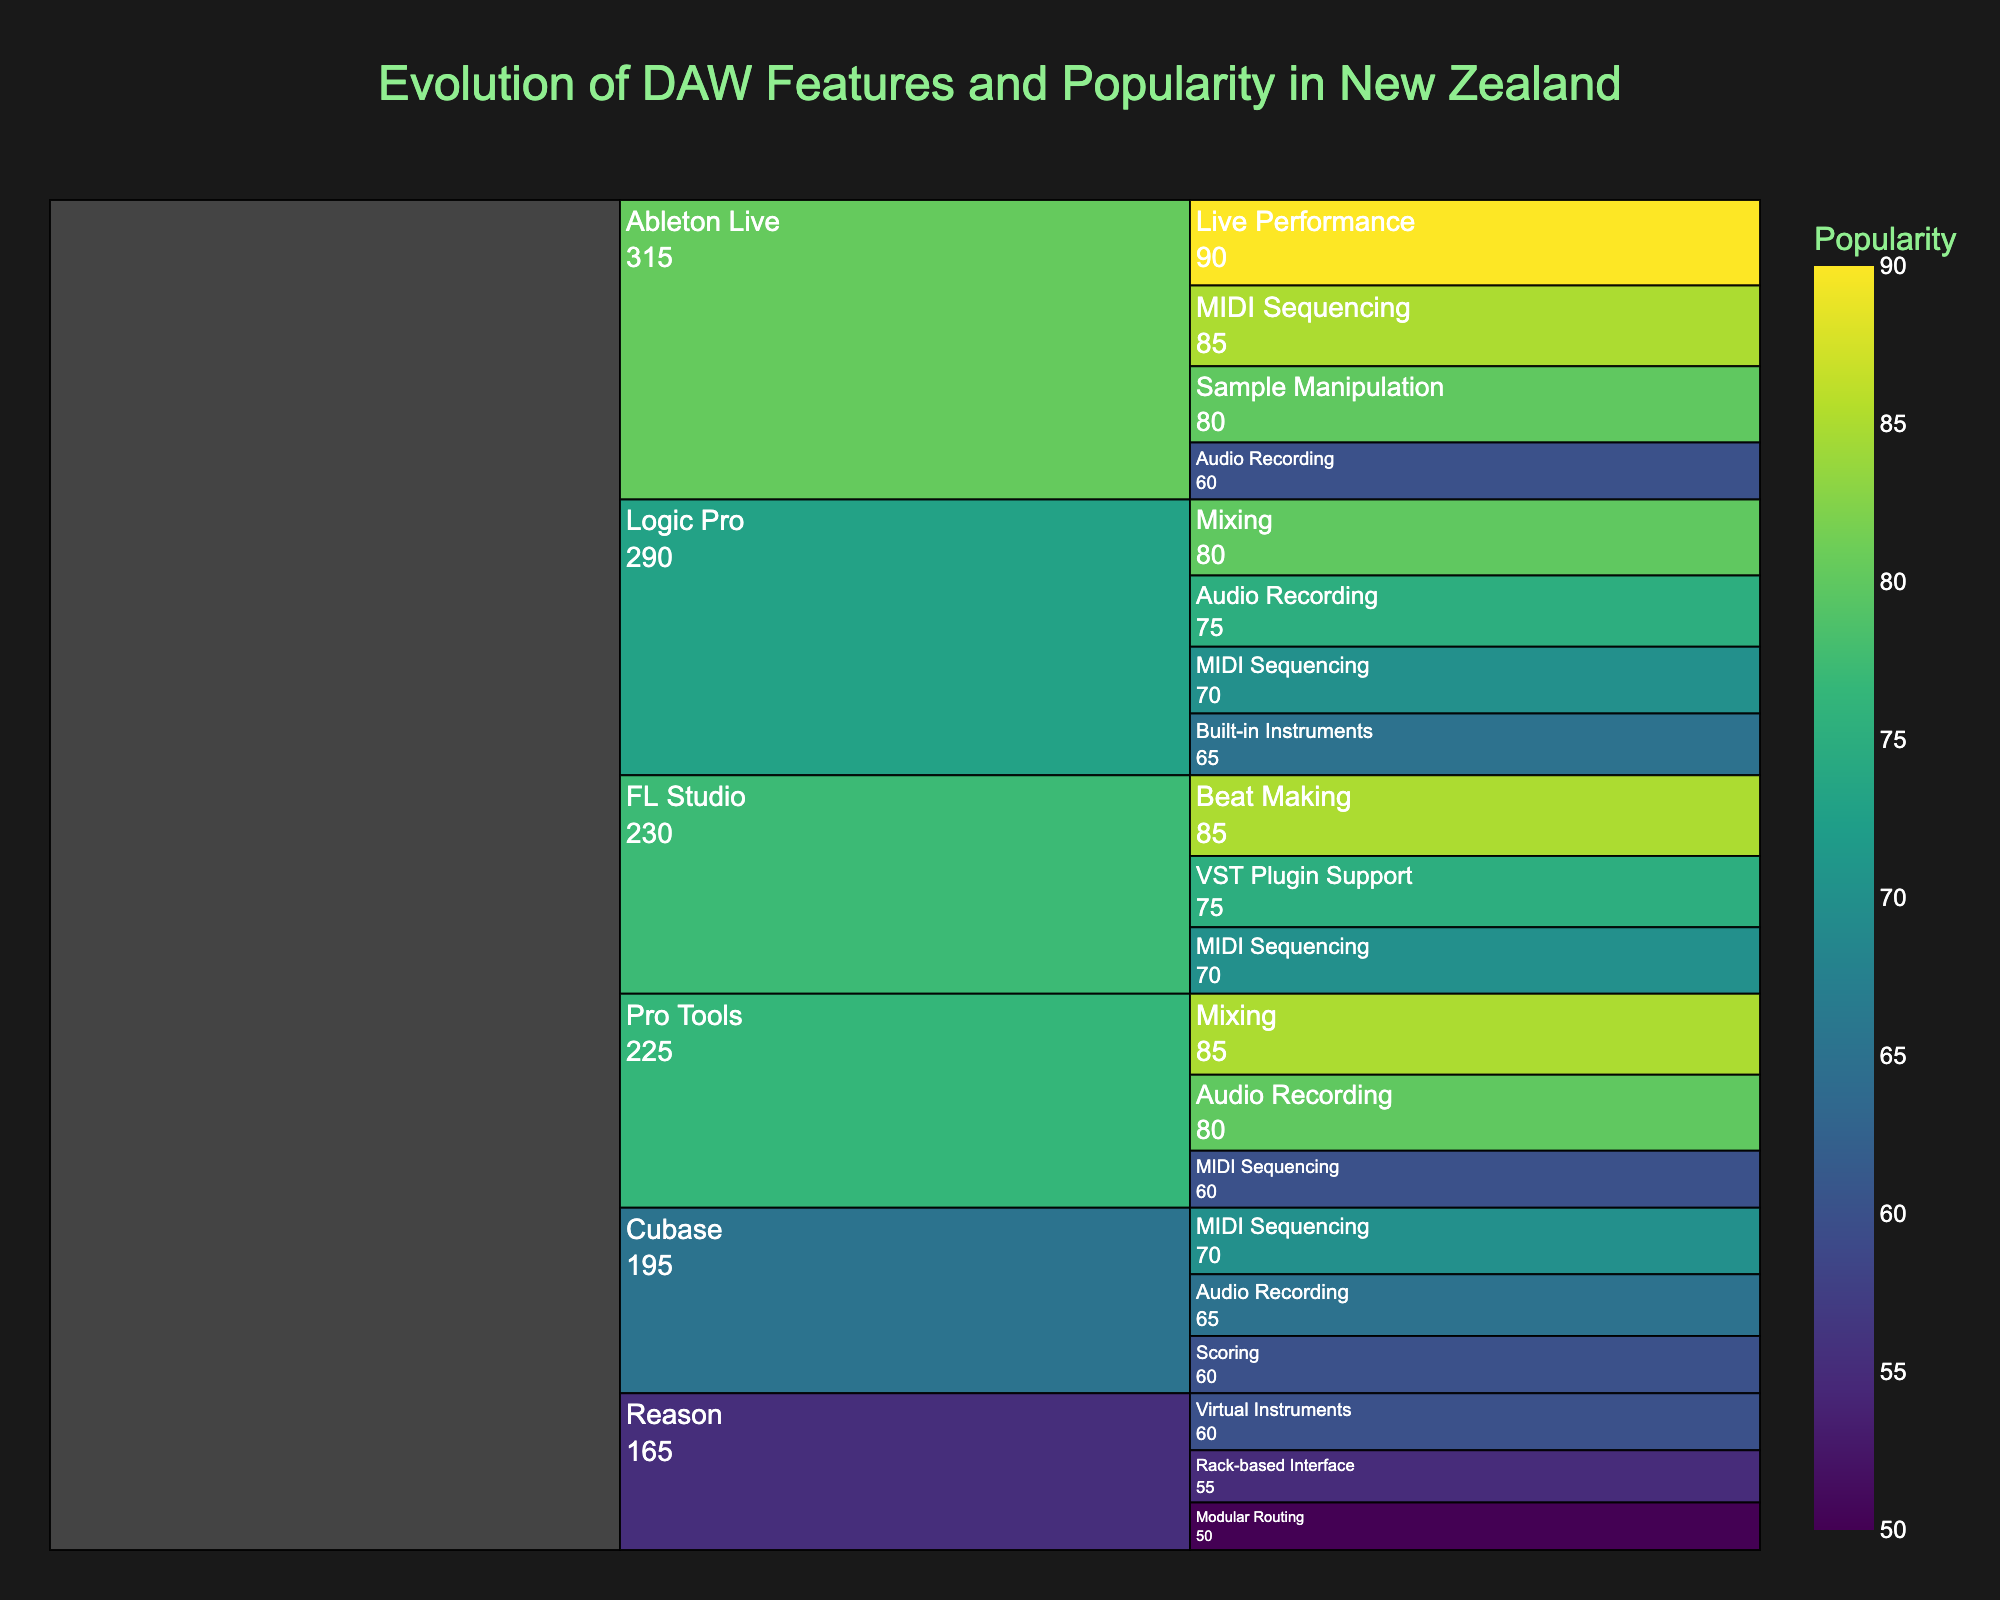What is the title of the Icicle Chart? The title is generally placed at the top of the chart and gives an overview of the content. Here, it is "Evolution of DAW Features and Popularity in New Zealand".
Answer: Evolution of DAW Features and Popularity in New Zealand Which DAW has the highest popularity for a specific feature? The chart uses color intensity to represent popularity values. Ableton Live with Live Performance has the highest popularity, indicated by the highest value (90) in the chart.
Answer: Ableton Live with Live Performance How many features does Logic Pro have listed in the chart? By tracing the Logic Pro label in the Icicle Chart, we see it branches into four features: Audio Recording, MIDI Sequencing, Mixing, and Built-in Instruments.
Answer: 4 Which feature in FL Studio has the highest and lowest popularity? Under FL Studio, compare the popularity values of all listed features. Beat Making has the highest popularity (85), and MIDI Sequencing has the lowest (70).
Answer: Highest: Beat Making, Lowest: MIDI Sequencing What is the average popularity of the features listed under Pro Tools? Add the popularity values for Pro Tools features (Audio Recording: 80, MIDI Sequencing: 60, Mixing: 85) to get 225. Divide by the number of features (3), resulting in an average of 75.
Answer: 75 What feature under Cubase is least popular? Inspect the branch under Cubase and compare the popularity values; Scoring has the lowest popularity (60).
Answer: Scoring Which DAW has the most features listed? Count the number of features for each DAW: Logic Pro (4), Pro Tools (3), Ableton Live (4), FL Studio (3), Cubase (3), and Reason (3). Logic Pro and Ableton Live both have the most with 4 features each.
Answer: Logic Pro and Ableton Live Compare the popularity of MIDI Sequencing in Pro Tools and Cubase. Which is higher? Look at the popularity values for MIDI Sequencing in both DAWs; Pro Tools has a value of 60, and Cubase has a value of 70, making Cubase higher.
Answer: Cubase What is the total popularity sum for all features in Reason? Add up the popularity values for Virtual Instruments (60), Rack-based Interface (55), and Modular Routing (50). Total = 60 + 55 + 50 = 165.
Answer: 165 